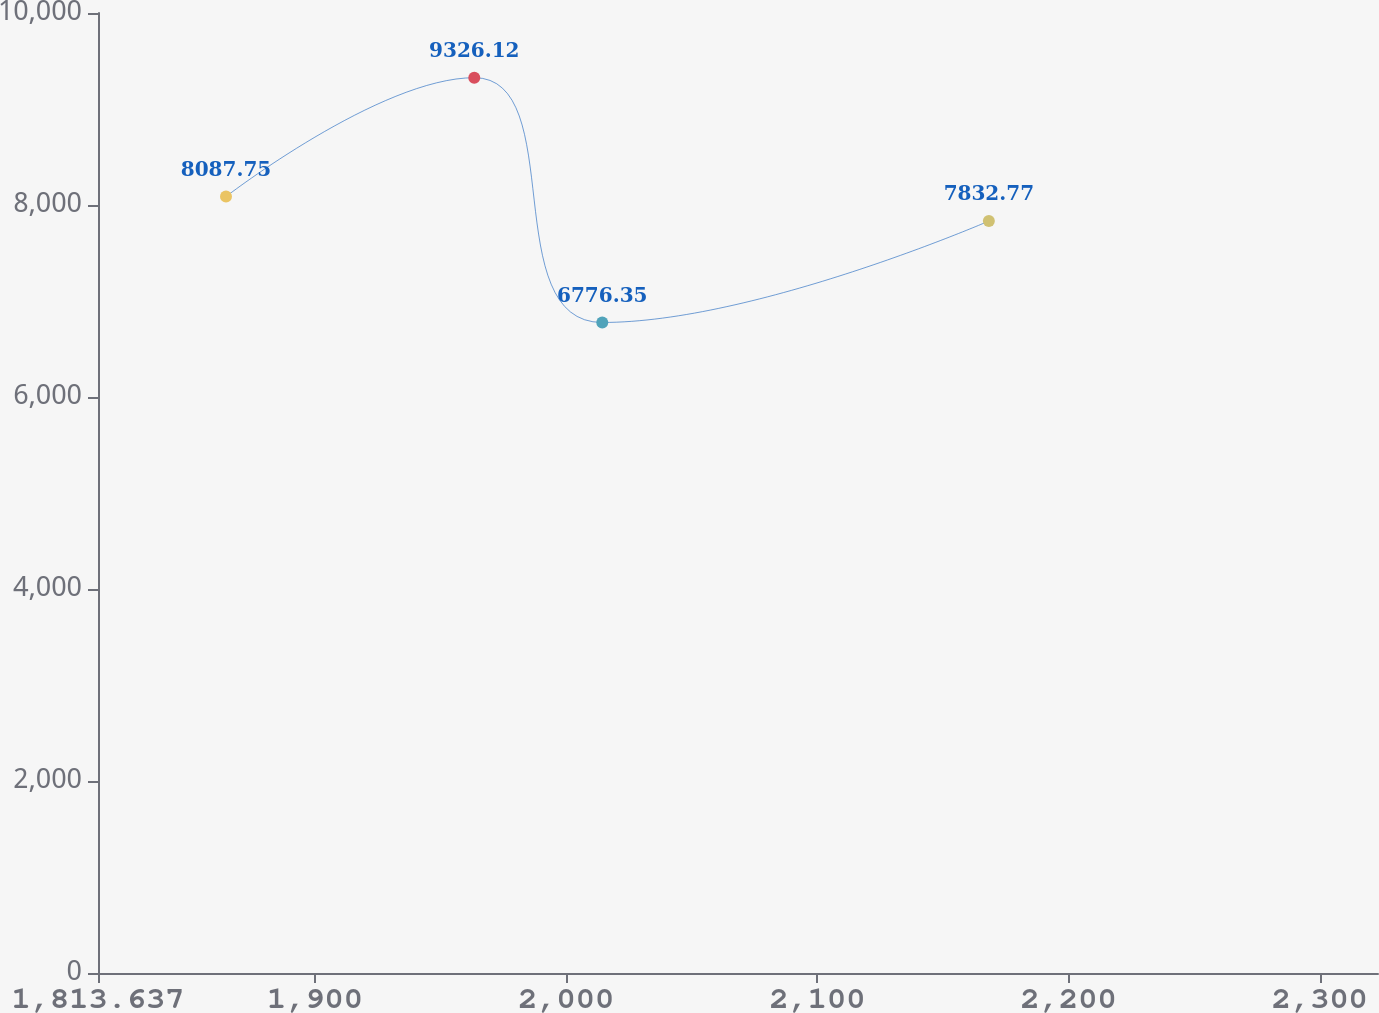Convert chart to OTSL. <chart><loc_0><loc_0><loc_500><loc_500><line_chart><ecel><fcel>Amount<nl><fcel>1864.59<fcel>8087.75<nl><fcel>1963.42<fcel>9326.12<nl><fcel>2014.37<fcel>6776.35<nl><fcel>2168.26<fcel>7832.77<nl><fcel>2374.12<fcel>7577.79<nl></chart> 